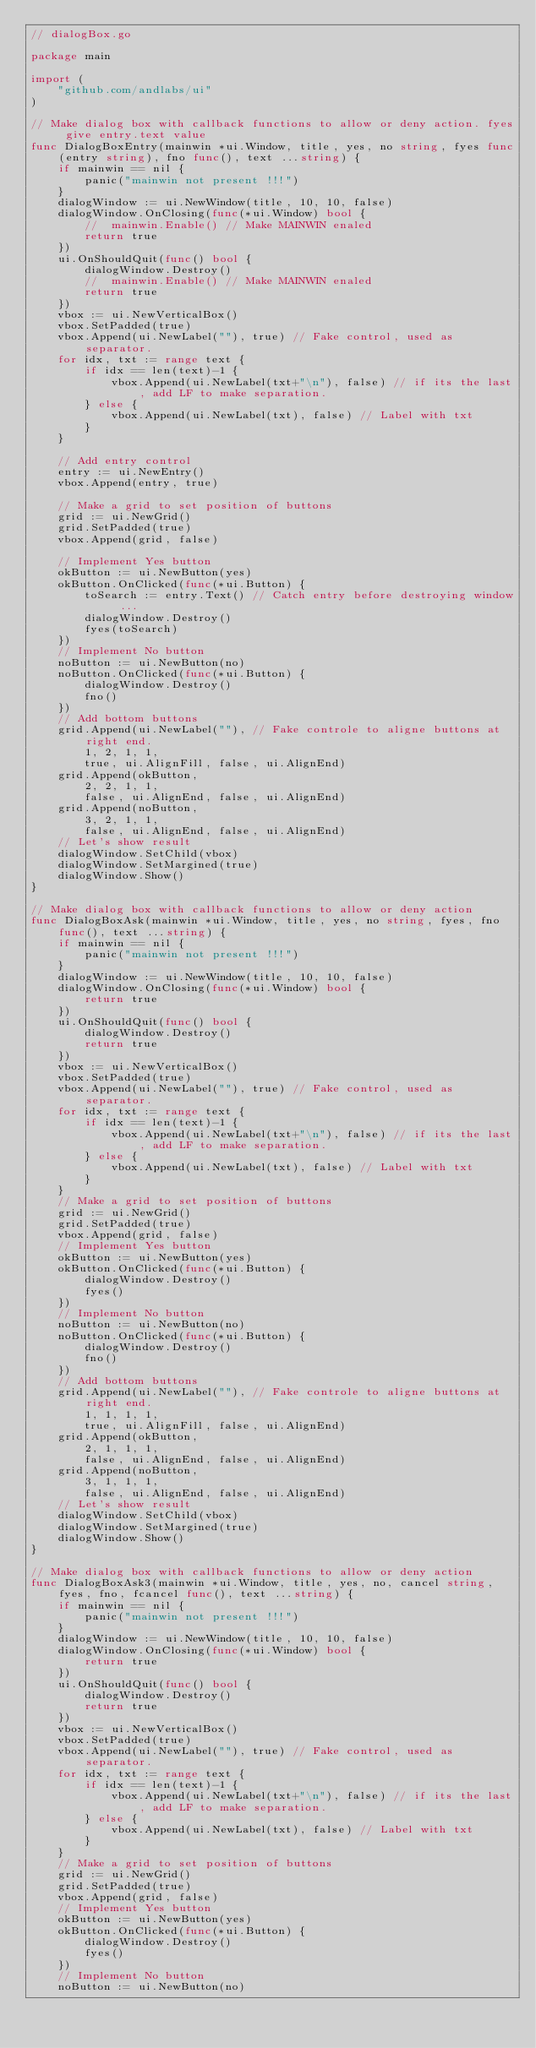<code> <loc_0><loc_0><loc_500><loc_500><_Go_>// dialogBox.go

package main

import (
	"github.com/andlabs/ui"
)

// Make dialog box with callback functions to allow or deny action. fyes give entry.text value
func DialogBoxEntry(mainwin *ui.Window, title, yes, no string, fyes func(entry string), fno func(), text ...string) {
	if mainwin == nil {
		panic("mainwin not present !!!")
	}
	dialogWindow := ui.NewWindow(title, 10, 10, false)
	dialogWindow.OnClosing(func(*ui.Window) bool {
		//	mainwin.Enable() // Make MAINWIN enaled
		return true
	})
	ui.OnShouldQuit(func() bool {
		dialogWindow.Destroy()
		//	mainwin.Enable() // Make MAINWIN enaled
		return true
	})
	vbox := ui.NewVerticalBox()
	vbox.SetPadded(true)
	vbox.Append(ui.NewLabel(""), true) // Fake control, used as separator.
	for idx, txt := range text {
		if idx == len(text)-1 {
			vbox.Append(ui.NewLabel(txt+"\n"), false) // if its the last, add LF to make separation.
		} else {
			vbox.Append(ui.NewLabel(txt), false) // Label with txt
		}
	}

	// Add entry control
	entry := ui.NewEntry()
	vbox.Append(entry, true)

	// Make a grid to set position of buttons
	grid := ui.NewGrid()
	grid.SetPadded(true)
	vbox.Append(grid, false)

	// Implement Yes button
	okButton := ui.NewButton(yes)
	okButton.OnClicked(func(*ui.Button) {
		toSearch := entry.Text() // Catch entry before destroying window ...
		dialogWindow.Destroy()
		fyes(toSearch)
	})
	// Implement No button
	noButton := ui.NewButton(no)
	noButton.OnClicked(func(*ui.Button) {
		dialogWindow.Destroy()
		fno()
	})
	// Add bottom buttons
	grid.Append(ui.NewLabel(""), // Fake controle to aligne buttons at right end.
		1, 2, 1, 1,
		true, ui.AlignFill, false, ui.AlignEnd)
	grid.Append(okButton,
		2, 2, 1, 1,
		false, ui.AlignEnd, false, ui.AlignEnd)
	grid.Append(noButton,
		3, 2, 1, 1,
		false, ui.AlignEnd, false, ui.AlignEnd)
	// Let's show result
	dialogWindow.SetChild(vbox)
	dialogWindow.SetMargined(true)
	dialogWindow.Show()
}

// Make dialog box with callback functions to allow or deny action
func DialogBoxAsk(mainwin *ui.Window, title, yes, no string, fyes, fno func(), text ...string) {
	if mainwin == nil {
		panic("mainwin not present !!!")
	}
	dialogWindow := ui.NewWindow(title, 10, 10, false)
	dialogWindow.OnClosing(func(*ui.Window) bool {
		return true
	})
	ui.OnShouldQuit(func() bool {
		dialogWindow.Destroy()
		return true
	})
	vbox := ui.NewVerticalBox()
	vbox.SetPadded(true)
	vbox.Append(ui.NewLabel(""), true) // Fake control, used as separator.
	for idx, txt := range text {
		if idx == len(text)-1 {
			vbox.Append(ui.NewLabel(txt+"\n"), false) // if its the last, add LF to make separation.
		} else {
			vbox.Append(ui.NewLabel(txt), false) // Label with txt
		}
	}
	// Make a grid to set position of buttons
	grid := ui.NewGrid()
	grid.SetPadded(true)
	vbox.Append(grid, false)
	// Implement Yes button
	okButton := ui.NewButton(yes)
	okButton.OnClicked(func(*ui.Button) {
		dialogWindow.Destroy()
		fyes()
	})
	// Implement No button
	noButton := ui.NewButton(no)
	noButton.OnClicked(func(*ui.Button) {
		dialogWindow.Destroy()
		fno()
	})
	// Add bottom buttons
	grid.Append(ui.NewLabel(""), // Fake controle to aligne buttons at right end.
		1, 1, 1, 1,
		true, ui.AlignFill, false, ui.AlignEnd)
	grid.Append(okButton,
		2, 1, 1, 1,
		false, ui.AlignEnd, false, ui.AlignEnd)
	grid.Append(noButton,
		3, 1, 1, 1,
		false, ui.AlignEnd, false, ui.AlignEnd)
	// Let's show result
	dialogWindow.SetChild(vbox)
	dialogWindow.SetMargined(true)
	dialogWindow.Show()
}

// Make dialog box with callback functions to allow or deny action
func DialogBoxAsk3(mainwin *ui.Window, title, yes, no, cancel string, fyes, fno, fcancel func(), text ...string) {
	if mainwin == nil {
		panic("mainwin not present !!!")
	}
	dialogWindow := ui.NewWindow(title, 10, 10, false)
	dialogWindow.OnClosing(func(*ui.Window) bool {
		return true
	})
	ui.OnShouldQuit(func() bool {
		dialogWindow.Destroy()
		return true
	})
	vbox := ui.NewVerticalBox()
	vbox.SetPadded(true)
	vbox.Append(ui.NewLabel(""), true) // Fake control, used as separator.
	for idx, txt := range text {
		if idx == len(text)-1 {
			vbox.Append(ui.NewLabel(txt+"\n"), false) // if its the last, add LF to make separation.
		} else {
			vbox.Append(ui.NewLabel(txt), false) // Label with txt
		}
	}
	// Make a grid to set position of buttons
	grid := ui.NewGrid()
	grid.SetPadded(true)
	vbox.Append(grid, false)
	// Implement Yes button
	okButton := ui.NewButton(yes)
	okButton.OnClicked(func(*ui.Button) {
		dialogWindow.Destroy()
		fyes()
	})
	// Implement No button
	noButton := ui.NewButton(no)</code> 